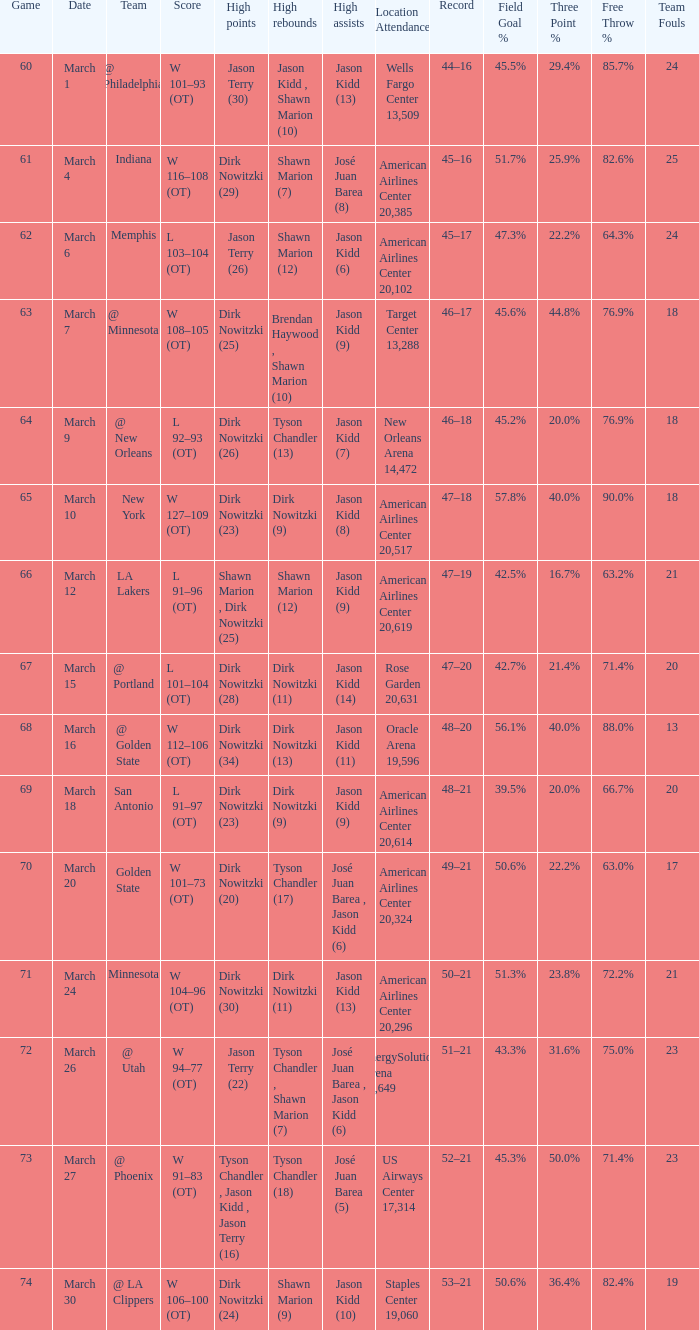Name the score for  josé juan barea (8) W 116–108 (OT). 